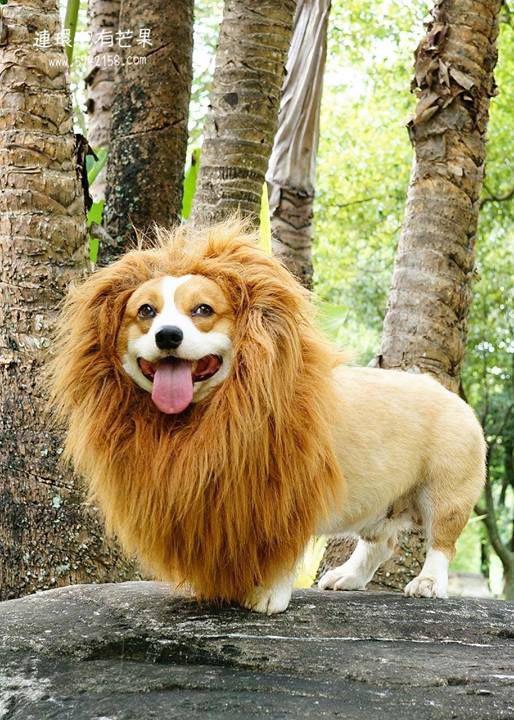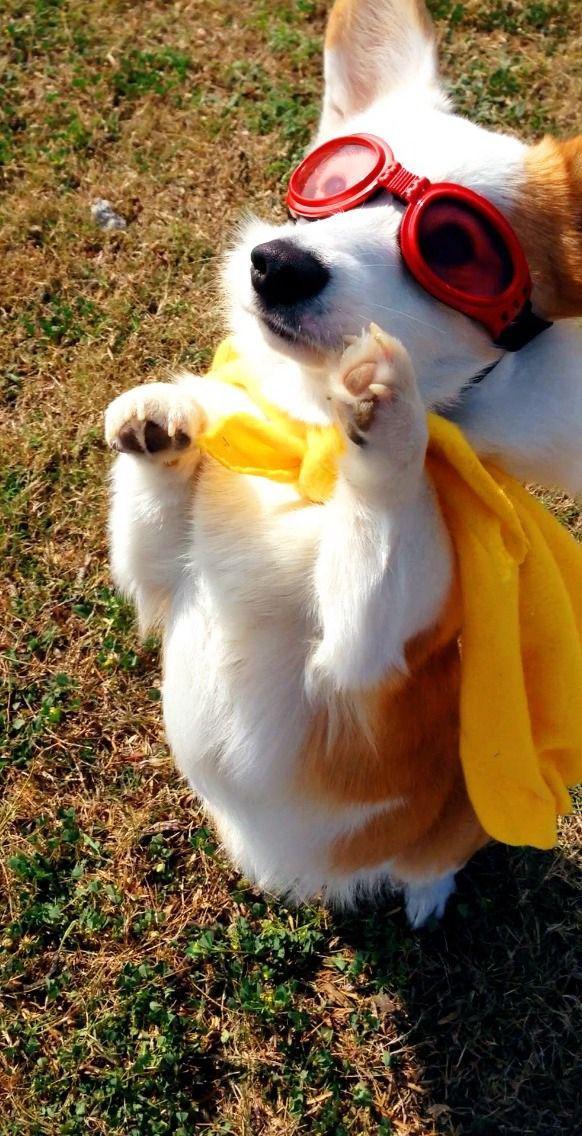The first image is the image on the left, the second image is the image on the right. Analyze the images presented: Is the assertion "There are two small dogs wearing costumes" valid? Answer yes or no. Yes. 